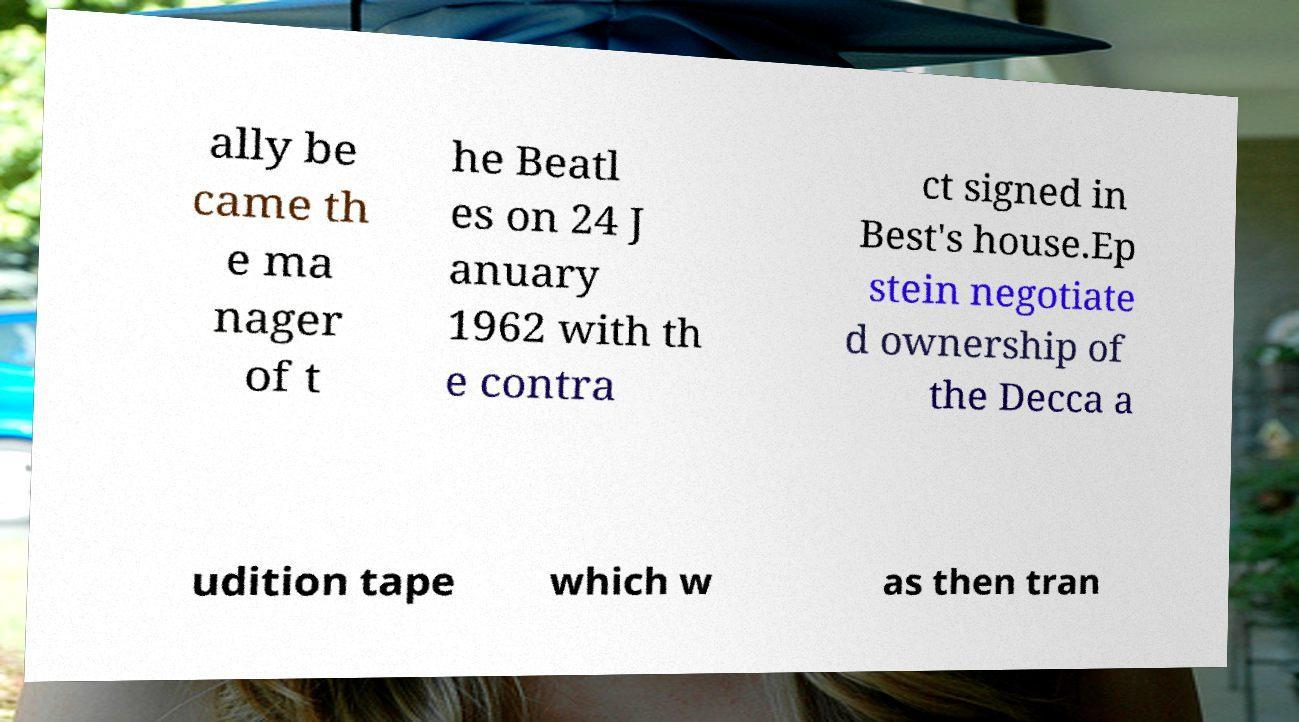Please read and relay the text visible in this image. What does it say? ally be came th e ma nager of t he Beatl es on 24 J anuary 1962 with th e contra ct signed in Best's house.Ep stein negotiate d ownership of the Decca a udition tape which w as then tran 